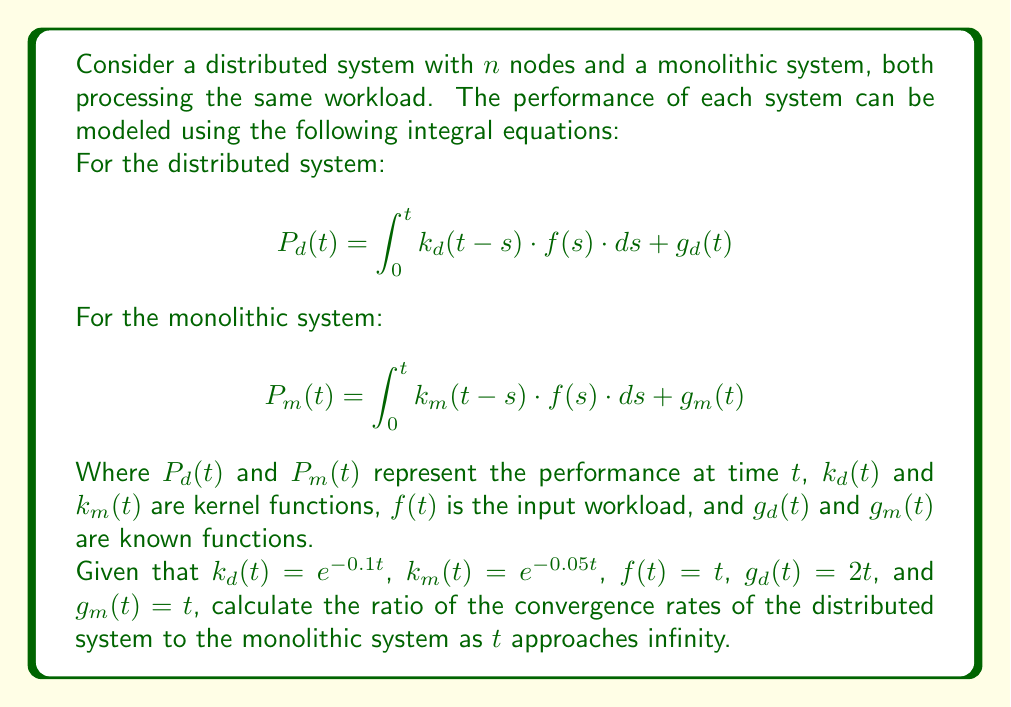Give your solution to this math problem. To solve this problem, we need to follow these steps:

1) First, let's solve the integral equations for both systems:

   For the distributed system:
   $$ P_d(t) = \int_0^t e^{-0.1(t-s)} \cdot s \cdot ds + 2t $$

   For the monolithic system:
   $$ P_m(t) = \int_0^t e^{-0.05(t-s)} \cdot s \cdot ds + t $$

2) Let's solve these integrals:

   For $P_d(t)$:
   $$ \begin{align}
   P_d(t) &= e^{-0.1t} \int_0^t e^{0.1s} \cdot s \cdot ds + 2t \\
   &= e^{-0.1t} \left[ \frac{1}{0.1^2}(0.1s-1)e^{0.1s} \right]_0^t + 2t \\
   &= \frac{1}{0.01}(0.1t-1+e^{-0.1t}) + 2t \\
   &= 10t - 100 + 100e^{-0.1t} + 2t \\
   &= 12t - 100 + 100e^{-0.1t}
   \end{align} $$

   For $P_m(t)$:
   $$ \begin{align}
   P_m(t) &= e^{-0.05t} \int_0^t e^{0.05s} \cdot s \cdot ds + t \\
   &= e^{-0.05t} \left[ \frac{1}{0.05^2}(0.05s-1)e^{0.05s} \right]_0^t + t \\
   &= \frac{1}{0.0025}(0.05t-1+e^{-0.05t}) + t \\
   &= 20t - 400 + 400e^{-0.05t} + t \\
   &= 21t - 400 + 400e^{-0.05t}
   \end{align} $$

3) To find the convergence rate, we need to look at the behavior of these functions as $t$ approaches infinity:

   For $P_d(t)$:
   $$ \lim_{t \to \infty} P_d(t) = \lim_{t \to \infty} (12t - 100 + 100e^{-0.1t}) = \infty $$

   For $P_m(t)$:
   $$ \lim_{t \to \infty} P_m(t) = \lim_{t \to \infty} (21t - 400 + 400e^{-0.05t}) = \infty $$

4) Both systems diverge to infinity, but at different rates. The convergence rate is determined by the coefficient of $t$ in each function.

5) The ratio of the convergence rates is:
   $$ \frac{\text{Rate of Distributed}}{\text{Rate of Monolithic}} = \frac{12}{21} = \frac{4}{7} $$

This means the distributed system converges (or in this case, diverges) at 4/7 the rate of the monolithic system.
Answer: $\frac{4}{7}$ 